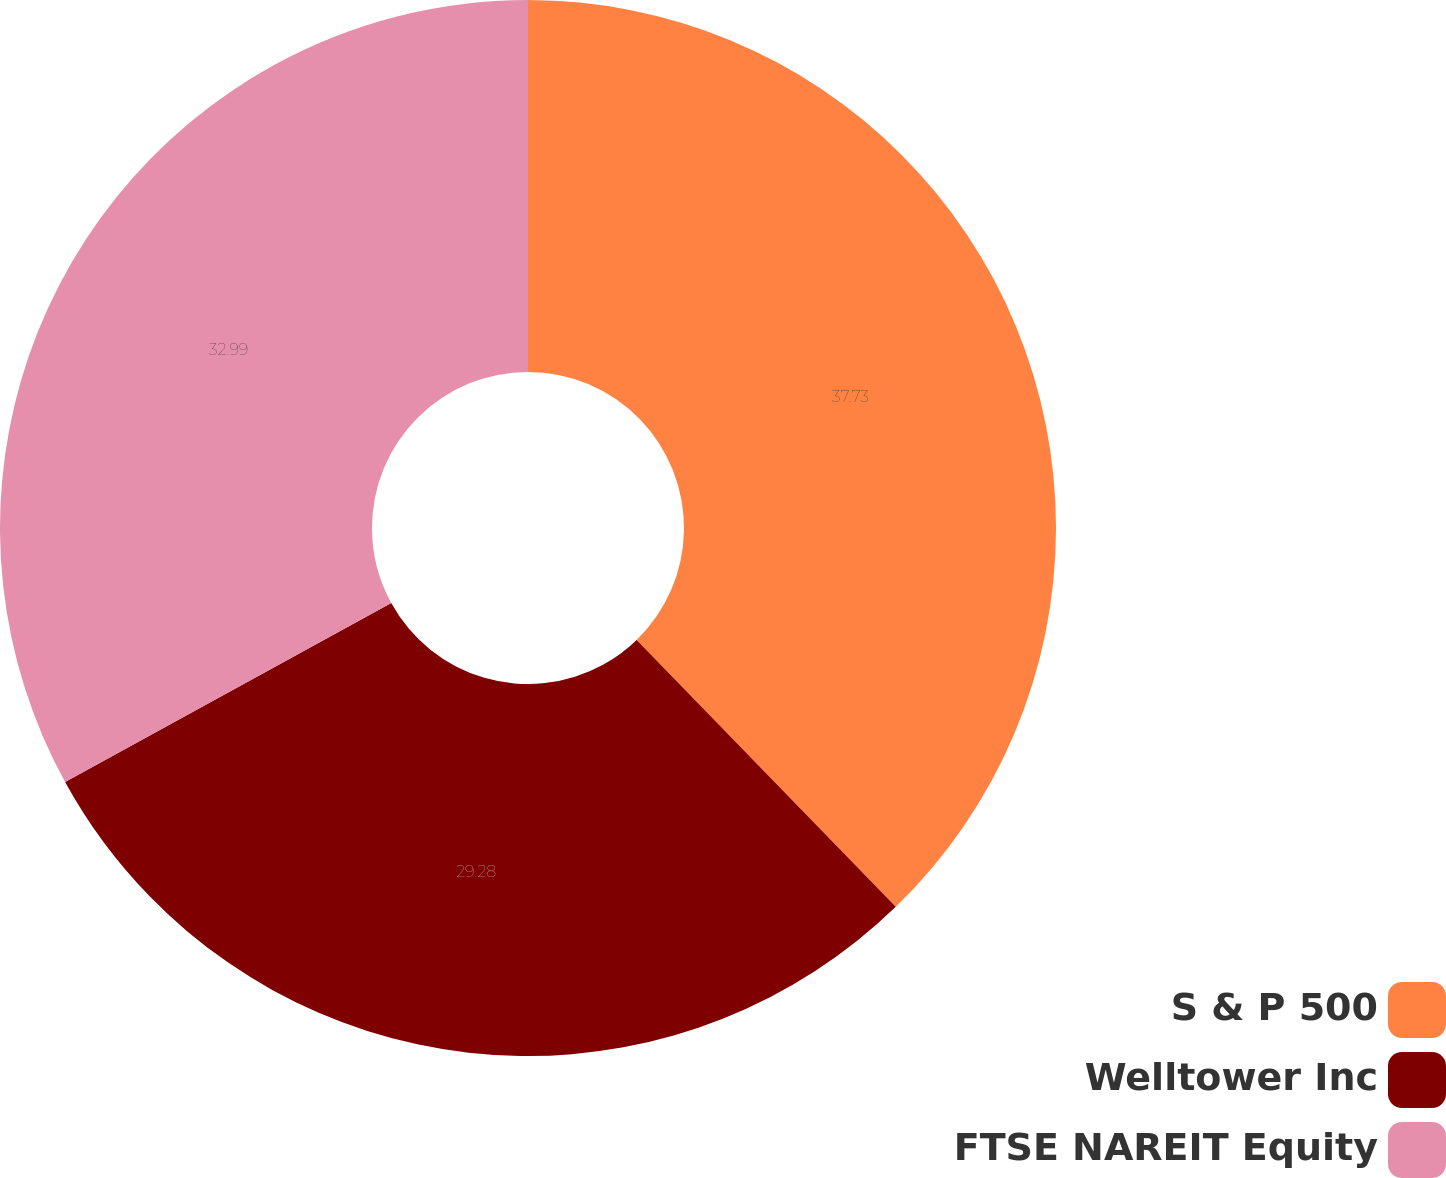Convert chart. <chart><loc_0><loc_0><loc_500><loc_500><pie_chart><fcel>S & P 500<fcel>Welltower Inc<fcel>FTSE NAREIT Equity<nl><fcel>37.74%<fcel>29.28%<fcel>32.99%<nl></chart> 